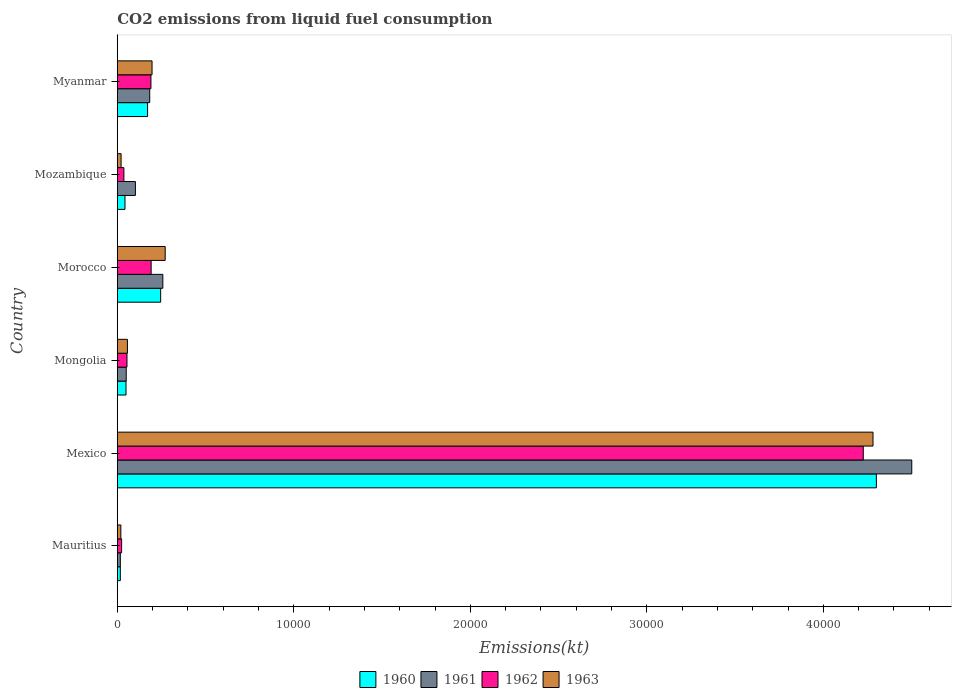Are the number of bars per tick equal to the number of legend labels?
Your answer should be compact. Yes. Are the number of bars on each tick of the Y-axis equal?
Your answer should be very brief. Yes. What is the label of the 5th group of bars from the top?
Give a very brief answer. Mexico. What is the amount of CO2 emitted in 1962 in Mexico?
Offer a terse response. 4.23e+04. Across all countries, what is the maximum amount of CO2 emitted in 1960?
Provide a short and direct response. 4.30e+04. Across all countries, what is the minimum amount of CO2 emitted in 1963?
Offer a terse response. 201.69. In which country was the amount of CO2 emitted in 1963 minimum?
Make the answer very short. Mauritius. What is the total amount of CO2 emitted in 1961 in the graph?
Your response must be concise. 5.11e+04. What is the difference between the amount of CO2 emitted in 1960 in Mexico and that in Myanmar?
Your answer should be very brief. 4.13e+04. What is the difference between the amount of CO2 emitted in 1961 in Morocco and the amount of CO2 emitted in 1963 in Mexico?
Keep it short and to the point. -4.02e+04. What is the average amount of CO2 emitted in 1960 per country?
Offer a very short reply. 8046.62. What is the difference between the amount of CO2 emitted in 1960 and amount of CO2 emitted in 1961 in Myanmar?
Your answer should be very brief. -121.01. What is the ratio of the amount of CO2 emitted in 1963 in Mongolia to that in Myanmar?
Give a very brief answer. 0.29. Is the amount of CO2 emitted in 1960 in Mexico less than that in Morocco?
Your answer should be compact. No. What is the difference between the highest and the second highest amount of CO2 emitted in 1963?
Ensure brevity in your answer.  4.01e+04. What is the difference between the highest and the lowest amount of CO2 emitted in 1962?
Make the answer very short. 4.20e+04. What does the 3rd bar from the top in Mozambique represents?
Make the answer very short. 1961. Is it the case that in every country, the sum of the amount of CO2 emitted in 1961 and amount of CO2 emitted in 1960 is greater than the amount of CO2 emitted in 1963?
Offer a very short reply. Yes. Are all the bars in the graph horizontal?
Provide a short and direct response. Yes. How many countries are there in the graph?
Your answer should be very brief. 6. What is the difference between two consecutive major ticks on the X-axis?
Your answer should be compact. 10000. Are the values on the major ticks of X-axis written in scientific E-notation?
Provide a short and direct response. No. Does the graph contain grids?
Provide a short and direct response. No. Where does the legend appear in the graph?
Provide a succinct answer. Bottom center. How many legend labels are there?
Provide a short and direct response. 4. What is the title of the graph?
Provide a short and direct response. CO2 emissions from liquid fuel consumption. What is the label or title of the X-axis?
Give a very brief answer. Emissions(kt). What is the label or title of the Y-axis?
Provide a succinct answer. Country. What is the Emissions(kt) of 1960 in Mauritius?
Make the answer very short. 172.35. What is the Emissions(kt) in 1961 in Mauritius?
Make the answer very short. 172.35. What is the Emissions(kt) in 1962 in Mauritius?
Make the answer very short. 245.69. What is the Emissions(kt) of 1963 in Mauritius?
Provide a short and direct response. 201.69. What is the Emissions(kt) in 1960 in Mexico?
Provide a short and direct response. 4.30e+04. What is the Emissions(kt) of 1961 in Mexico?
Your response must be concise. 4.50e+04. What is the Emissions(kt) of 1962 in Mexico?
Your response must be concise. 4.23e+04. What is the Emissions(kt) of 1963 in Mexico?
Your response must be concise. 4.28e+04. What is the Emissions(kt) in 1960 in Mongolia?
Provide a succinct answer. 495.05. What is the Emissions(kt) in 1961 in Mongolia?
Give a very brief answer. 506.05. What is the Emissions(kt) in 1962 in Mongolia?
Ensure brevity in your answer.  550.05. What is the Emissions(kt) of 1963 in Mongolia?
Offer a very short reply. 575.72. What is the Emissions(kt) of 1960 in Morocco?
Make the answer very short. 2456.89. What is the Emissions(kt) of 1961 in Morocco?
Offer a terse response. 2581.57. What is the Emissions(kt) of 1962 in Morocco?
Ensure brevity in your answer.  1917.84. What is the Emissions(kt) in 1963 in Morocco?
Your response must be concise. 2713.58. What is the Emissions(kt) of 1960 in Mozambique?
Provide a succinct answer. 436.37. What is the Emissions(kt) in 1961 in Mozambique?
Your answer should be very brief. 1026.76. What is the Emissions(kt) in 1962 in Mozambique?
Give a very brief answer. 374.03. What is the Emissions(kt) of 1963 in Mozambique?
Your response must be concise. 216.35. What is the Emissions(kt) of 1960 in Myanmar?
Keep it short and to the point. 1716.16. What is the Emissions(kt) of 1961 in Myanmar?
Provide a short and direct response. 1837.17. What is the Emissions(kt) of 1962 in Myanmar?
Make the answer very short. 1906.84. What is the Emissions(kt) in 1963 in Myanmar?
Your response must be concise. 1969.18. Across all countries, what is the maximum Emissions(kt) in 1960?
Your answer should be compact. 4.30e+04. Across all countries, what is the maximum Emissions(kt) in 1961?
Make the answer very short. 4.50e+04. Across all countries, what is the maximum Emissions(kt) of 1962?
Provide a succinct answer. 4.23e+04. Across all countries, what is the maximum Emissions(kt) in 1963?
Your answer should be compact. 4.28e+04. Across all countries, what is the minimum Emissions(kt) of 1960?
Provide a succinct answer. 172.35. Across all countries, what is the minimum Emissions(kt) in 1961?
Your answer should be very brief. 172.35. Across all countries, what is the minimum Emissions(kt) of 1962?
Your answer should be very brief. 245.69. Across all countries, what is the minimum Emissions(kt) of 1963?
Your response must be concise. 201.69. What is the total Emissions(kt) of 1960 in the graph?
Offer a terse response. 4.83e+04. What is the total Emissions(kt) of 1961 in the graph?
Your response must be concise. 5.11e+04. What is the total Emissions(kt) in 1962 in the graph?
Your response must be concise. 4.73e+04. What is the total Emissions(kt) in 1963 in the graph?
Offer a very short reply. 4.85e+04. What is the difference between the Emissions(kt) of 1960 in Mauritius and that in Mexico?
Offer a terse response. -4.28e+04. What is the difference between the Emissions(kt) of 1961 in Mauritius and that in Mexico?
Your answer should be very brief. -4.48e+04. What is the difference between the Emissions(kt) of 1962 in Mauritius and that in Mexico?
Your answer should be compact. -4.20e+04. What is the difference between the Emissions(kt) in 1963 in Mauritius and that in Mexico?
Provide a short and direct response. -4.26e+04. What is the difference between the Emissions(kt) of 1960 in Mauritius and that in Mongolia?
Your answer should be very brief. -322.7. What is the difference between the Emissions(kt) of 1961 in Mauritius and that in Mongolia?
Offer a terse response. -333.7. What is the difference between the Emissions(kt) in 1962 in Mauritius and that in Mongolia?
Provide a succinct answer. -304.36. What is the difference between the Emissions(kt) in 1963 in Mauritius and that in Mongolia?
Provide a succinct answer. -374.03. What is the difference between the Emissions(kt) in 1960 in Mauritius and that in Morocco?
Your answer should be compact. -2284.54. What is the difference between the Emissions(kt) in 1961 in Mauritius and that in Morocco?
Provide a short and direct response. -2409.22. What is the difference between the Emissions(kt) in 1962 in Mauritius and that in Morocco?
Ensure brevity in your answer.  -1672.15. What is the difference between the Emissions(kt) of 1963 in Mauritius and that in Morocco?
Ensure brevity in your answer.  -2511.89. What is the difference between the Emissions(kt) in 1960 in Mauritius and that in Mozambique?
Provide a short and direct response. -264.02. What is the difference between the Emissions(kt) of 1961 in Mauritius and that in Mozambique?
Offer a very short reply. -854.41. What is the difference between the Emissions(kt) in 1962 in Mauritius and that in Mozambique?
Keep it short and to the point. -128.34. What is the difference between the Emissions(kt) of 1963 in Mauritius and that in Mozambique?
Make the answer very short. -14.67. What is the difference between the Emissions(kt) in 1960 in Mauritius and that in Myanmar?
Your response must be concise. -1543.81. What is the difference between the Emissions(kt) in 1961 in Mauritius and that in Myanmar?
Keep it short and to the point. -1664.82. What is the difference between the Emissions(kt) of 1962 in Mauritius and that in Myanmar?
Keep it short and to the point. -1661.15. What is the difference between the Emissions(kt) in 1963 in Mauritius and that in Myanmar?
Your answer should be very brief. -1767.49. What is the difference between the Emissions(kt) in 1960 in Mexico and that in Mongolia?
Your answer should be compact. 4.25e+04. What is the difference between the Emissions(kt) in 1961 in Mexico and that in Mongolia?
Provide a succinct answer. 4.45e+04. What is the difference between the Emissions(kt) in 1962 in Mexico and that in Mongolia?
Provide a short and direct response. 4.17e+04. What is the difference between the Emissions(kt) of 1963 in Mexico and that in Mongolia?
Offer a terse response. 4.22e+04. What is the difference between the Emissions(kt) of 1960 in Mexico and that in Morocco?
Ensure brevity in your answer.  4.05e+04. What is the difference between the Emissions(kt) of 1961 in Mexico and that in Morocco?
Provide a succinct answer. 4.24e+04. What is the difference between the Emissions(kt) in 1962 in Mexico and that in Morocco?
Make the answer very short. 4.03e+04. What is the difference between the Emissions(kt) of 1963 in Mexico and that in Morocco?
Your response must be concise. 4.01e+04. What is the difference between the Emissions(kt) in 1960 in Mexico and that in Mozambique?
Provide a succinct answer. 4.26e+04. What is the difference between the Emissions(kt) of 1961 in Mexico and that in Mozambique?
Make the answer very short. 4.40e+04. What is the difference between the Emissions(kt) in 1962 in Mexico and that in Mozambique?
Your answer should be compact. 4.19e+04. What is the difference between the Emissions(kt) in 1963 in Mexico and that in Mozambique?
Your answer should be very brief. 4.26e+04. What is the difference between the Emissions(kt) of 1960 in Mexico and that in Myanmar?
Keep it short and to the point. 4.13e+04. What is the difference between the Emissions(kt) of 1961 in Mexico and that in Myanmar?
Give a very brief answer. 4.32e+04. What is the difference between the Emissions(kt) in 1962 in Mexico and that in Myanmar?
Give a very brief answer. 4.04e+04. What is the difference between the Emissions(kt) in 1963 in Mexico and that in Myanmar?
Your response must be concise. 4.08e+04. What is the difference between the Emissions(kt) in 1960 in Mongolia and that in Morocco?
Offer a terse response. -1961.85. What is the difference between the Emissions(kt) of 1961 in Mongolia and that in Morocco?
Give a very brief answer. -2075.52. What is the difference between the Emissions(kt) of 1962 in Mongolia and that in Morocco?
Your answer should be very brief. -1367.79. What is the difference between the Emissions(kt) of 1963 in Mongolia and that in Morocco?
Your answer should be compact. -2137.86. What is the difference between the Emissions(kt) of 1960 in Mongolia and that in Mozambique?
Offer a very short reply. 58.67. What is the difference between the Emissions(kt) of 1961 in Mongolia and that in Mozambique?
Provide a short and direct response. -520.71. What is the difference between the Emissions(kt) in 1962 in Mongolia and that in Mozambique?
Give a very brief answer. 176.02. What is the difference between the Emissions(kt) in 1963 in Mongolia and that in Mozambique?
Give a very brief answer. 359.37. What is the difference between the Emissions(kt) in 1960 in Mongolia and that in Myanmar?
Offer a terse response. -1221.11. What is the difference between the Emissions(kt) in 1961 in Mongolia and that in Myanmar?
Provide a succinct answer. -1331.12. What is the difference between the Emissions(kt) of 1962 in Mongolia and that in Myanmar?
Ensure brevity in your answer.  -1356.79. What is the difference between the Emissions(kt) in 1963 in Mongolia and that in Myanmar?
Keep it short and to the point. -1393.46. What is the difference between the Emissions(kt) in 1960 in Morocco and that in Mozambique?
Your answer should be very brief. 2020.52. What is the difference between the Emissions(kt) in 1961 in Morocco and that in Mozambique?
Keep it short and to the point. 1554.81. What is the difference between the Emissions(kt) of 1962 in Morocco and that in Mozambique?
Ensure brevity in your answer.  1543.81. What is the difference between the Emissions(kt) of 1963 in Morocco and that in Mozambique?
Give a very brief answer. 2497.23. What is the difference between the Emissions(kt) in 1960 in Morocco and that in Myanmar?
Provide a succinct answer. 740.73. What is the difference between the Emissions(kt) in 1961 in Morocco and that in Myanmar?
Offer a terse response. 744.4. What is the difference between the Emissions(kt) in 1962 in Morocco and that in Myanmar?
Your response must be concise. 11. What is the difference between the Emissions(kt) of 1963 in Morocco and that in Myanmar?
Make the answer very short. 744.4. What is the difference between the Emissions(kt) in 1960 in Mozambique and that in Myanmar?
Provide a short and direct response. -1279.78. What is the difference between the Emissions(kt) in 1961 in Mozambique and that in Myanmar?
Your response must be concise. -810.41. What is the difference between the Emissions(kt) in 1962 in Mozambique and that in Myanmar?
Offer a very short reply. -1532.81. What is the difference between the Emissions(kt) in 1963 in Mozambique and that in Myanmar?
Provide a succinct answer. -1752.83. What is the difference between the Emissions(kt) of 1960 in Mauritius and the Emissions(kt) of 1961 in Mexico?
Make the answer very short. -4.48e+04. What is the difference between the Emissions(kt) of 1960 in Mauritius and the Emissions(kt) of 1962 in Mexico?
Keep it short and to the point. -4.21e+04. What is the difference between the Emissions(kt) of 1960 in Mauritius and the Emissions(kt) of 1963 in Mexico?
Your answer should be very brief. -4.26e+04. What is the difference between the Emissions(kt) in 1961 in Mauritius and the Emissions(kt) in 1962 in Mexico?
Provide a short and direct response. -4.21e+04. What is the difference between the Emissions(kt) in 1961 in Mauritius and the Emissions(kt) in 1963 in Mexico?
Your answer should be very brief. -4.26e+04. What is the difference between the Emissions(kt) in 1962 in Mauritius and the Emissions(kt) in 1963 in Mexico?
Offer a very short reply. -4.26e+04. What is the difference between the Emissions(kt) of 1960 in Mauritius and the Emissions(kt) of 1961 in Mongolia?
Give a very brief answer. -333.7. What is the difference between the Emissions(kt) in 1960 in Mauritius and the Emissions(kt) in 1962 in Mongolia?
Provide a short and direct response. -377.7. What is the difference between the Emissions(kt) of 1960 in Mauritius and the Emissions(kt) of 1963 in Mongolia?
Make the answer very short. -403.37. What is the difference between the Emissions(kt) of 1961 in Mauritius and the Emissions(kt) of 1962 in Mongolia?
Provide a short and direct response. -377.7. What is the difference between the Emissions(kt) of 1961 in Mauritius and the Emissions(kt) of 1963 in Mongolia?
Ensure brevity in your answer.  -403.37. What is the difference between the Emissions(kt) of 1962 in Mauritius and the Emissions(kt) of 1963 in Mongolia?
Provide a succinct answer. -330.03. What is the difference between the Emissions(kt) in 1960 in Mauritius and the Emissions(kt) in 1961 in Morocco?
Provide a succinct answer. -2409.22. What is the difference between the Emissions(kt) of 1960 in Mauritius and the Emissions(kt) of 1962 in Morocco?
Offer a very short reply. -1745.49. What is the difference between the Emissions(kt) of 1960 in Mauritius and the Emissions(kt) of 1963 in Morocco?
Make the answer very short. -2541.23. What is the difference between the Emissions(kt) of 1961 in Mauritius and the Emissions(kt) of 1962 in Morocco?
Make the answer very short. -1745.49. What is the difference between the Emissions(kt) in 1961 in Mauritius and the Emissions(kt) in 1963 in Morocco?
Give a very brief answer. -2541.23. What is the difference between the Emissions(kt) in 1962 in Mauritius and the Emissions(kt) in 1963 in Morocco?
Your response must be concise. -2467.89. What is the difference between the Emissions(kt) of 1960 in Mauritius and the Emissions(kt) of 1961 in Mozambique?
Provide a succinct answer. -854.41. What is the difference between the Emissions(kt) in 1960 in Mauritius and the Emissions(kt) in 1962 in Mozambique?
Offer a very short reply. -201.69. What is the difference between the Emissions(kt) of 1960 in Mauritius and the Emissions(kt) of 1963 in Mozambique?
Your response must be concise. -44. What is the difference between the Emissions(kt) of 1961 in Mauritius and the Emissions(kt) of 1962 in Mozambique?
Your answer should be compact. -201.69. What is the difference between the Emissions(kt) in 1961 in Mauritius and the Emissions(kt) in 1963 in Mozambique?
Provide a succinct answer. -44. What is the difference between the Emissions(kt) of 1962 in Mauritius and the Emissions(kt) of 1963 in Mozambique?
Offer a very short reply. 29.34. What is the difference between the Emissions(kt) in 1960 in Mauritius and the Emissions(kt) in 1961 in Myanmar?
Your response must be concise. -1664.82. What is the difference between the Emissions(kt) in 1960 in Mauritius and the Emissions(kt) in 1962 in Myanmar?
Provide a short and direct response. -1734.49. What is the difference between the Emissions(kt) in 1960 in Mauritius and the Emissions(kt) in 1963 in Myanmar?
Give a very brief answer. -1796.83. What is the difference between the Emissions(kt) in 1961 in Mauritius and the Emissions(kt) in 1962 in Myanmar?
Your answer should be compact. -1734.49. What is the difference between the Emissions(kt) in 1961 in Mauritius and the Emissions(kt) in 1963 in Myanmar?
Your answer should be compact. -1796.83. What is the difference between the Emissions(kt) of 1962 in Mauritius and the Emissions(kt) of 1963 in Myanmar?
Provide a succinct answer. -1723.49. What is the difference between the Emissions(kt) in 1960 in Mexico and the Emissions(kt) in 1961 in Mongolia?
Your response must be concise. 4.25e+04. What is the difference between the Emissions(kt) of 1960 in Mexico and the Emissions(kt) of 1962 in Mongolia?
Provide a succinct answer. 4.25e+04. What is the difference between the Emissions(kt) in 1960 in Mexico and the Emissions(kt) in 1963 in Mongolia?
Offer a very short reply. 4.24e+04. What is the difference between the Emissions(kt) of 1961 in Mexico and the Emissions(kt) of 1962 in Mongolia?
Offer a terse response. 4.45e+04. What is the difference between the Emissions(kt) in 1961 in Mexico and the Emissions(kt) in 1963 in Mongolia?
Your answer should be very brief. 4.44e+04. What is the difference between the Emissions(kt) of 1962 in Mexico and the Emissions(kt) of 1963 in Mongolia?
Your response must be concise. 4.17e+04. What is the difference between the Emissions(kt) of 1960 in Mexico and the Emissions(kt) of 1961 in Morocco?
Keep it short and to the point. 4.04e+04. What is the difference between the Emissions(kt) in 1960 in Mexico and the Emissions(kt) in 1962 in Morocco?
Provide a short and direct response. 4.11e+04. What is the difference between the Emissions(kt) in 1960 in Mexico and the Emissions(kt) in 1963 in Morocco?
Offer a terse response. 4.03e+04. What is the difference between the Emissions(kt) in 1961 in Mexico and the Emissions(kt) in 1962 in Morocco?
Your answer should be compact. 4.31e+04. What is the difference between the Emissions(kt) of 1961 in Mexico and the Emissions(kt) of 1963 in Morocco?
Provide a short and direct response. 4.23e+04. What is the difference between the Emissions(kt) of 1962 in Mexico and the Emissions(kt) of 1963 in Morocco?
Your answer should be compact. 3.95e+04. What is the difference between the Emissions(kt) in 1960 in Mexico and the Emissions(kt) in 1961 in Mozambique?
Your answer should be compact. 4.20e+04. What is the difference between the Emissions(kt) in 1960 in Mexico and the Emissions(kt) in 1962 in Mozambique?
Give a very brief answer. 4.26e+04. What is the difference between the Emissions(kt) of 1960 in Mexico and the Emissions(kt) of 1963 in Mozambique?
Provide a succinct answer. 4.28e+04. What is the difference between the Emissions(kt) of 1961 in Mexico and the Emissions(kt) of 1962 in Mozambique?
Offer a terse response. 4.46e+04. What is the difference between the Emissions(kt) in 1961 in Mexico and the Emissions(kt) in 1963 in Mozambique?
Your response must be concise. 4.48e+04. What is the difference between the Emissions(kt) of 1962 in Mexico and the Emissions(kt) of 1963 in Mozambique?
Provide a short and direct response. 4.20e+04. What is the difference between the Emissions(kt) in 1960 in Mexico and the Emissions(kt) in 1961 in Myanmar?
Offer a very short reply. 4.12e+04. What is the difference between the Emissions(kt) of 1960 in Mexico and the Emissions(kt) of 1962 in Myanmar?
Make the answer very short. 4.11e+04. What is the difference between the Emissions(kt) in 1960 in Mexico and the Emissions(kt) in 1963 in Myanmar?
Ensure brevity in your answer.  4.10e+04. What is the difference between the Emissions(kt) of 1961 in Mexico and the Emissions(kt) of 1962 in Myanmar?
Offer a very short reply. 4.31e+04. What is the difference between the Emissions(kt) of 1961 in Mexico and the Emissions(kt) of 1963 in Myanmar?
Your response must be concise. 4.30e+04. What is the difference between the Emissions(kt) of 1962 in Mexico and the Emissions(kt) of 1963 in Myanmar?
Make the answer very short. 4.03e+04. What is the difference between the Emissions(kt) of 1960 in Mongolia and the Emissions(kt) of 1961 in Morocco?
Keep it short and to the point. -2086.52. What is the difference between the Emissions(kt) in 1960 in Mongolia and the Emissions(kt) in 1962 in Morocco?
Your answer should be very brief. -1422.8. What is the difference between the Emissions(kt) in 1960 in Mongolia and the Emissions(kt) in 1963 in Morocco?
Make the answer very short. -2218.53. What is the difference between the Emissions(kt) of 1961 in Mongolia and the Emissions(kt) of 1962 in Morocco?
Keep it short and to the point. -1411.8. What is the difference between the Emissions(kt) in 1961 in Mongolia and the Emissions(kt) in 1963 in Morocco?
Give a very brief answer. -2207.53. What is the difference between the Emissions(kt) of 1962 in Mongolia and the Emissions(kt) of 1963 in Morocco?
Keep it short and to the point. -2163.53. What is the difference between the Emissions(kt) in 1960 in Mongolia and the Emissions(kt) in 1961 in Mozambique?
Offer a very short reply. -531.72. What is the difference between the Emissions(kt) of 1960 in Mongolia and the Emissions(kt) of 1962 in Mozambique?
Your answer should be compact. 121.01. What is the difference between the Emissions(kt) of 1960 in Mongolia and the Emissions(kt) of 1963 in Mozambique?
Ensure brevity in your answer.  278.69. What is the difference between the Emissions(kt) in 1961 in Mongolia and the Emissions(kt) in 1962 in Mozambique?
Provide a succinct answer. 132.01. What is the difference between the Emissions(kt) in 1961 in Mongolia and the Emissions(kt) in 1963 in Mozambique?
Provide a short and direct response. 289.69. What is the difference between the Emissions(kt) in 1962 in Mongolia and the Emissions(kt) in 1963 in Mozambique?
Your answer should be very brief. 333.7. What is the difference between the Emissions(kt) in 1960 in Mongolia and the Emissions(kt) in 1961 in Myanmar?
Your response must be concise. -1342.12. What is the difference between the Emissions(kt) of 1960 in Mongolia and the Emissions(kt) of 1962 in Myanmar?
Your answer should be compact. -1411.8. What is the difference between the Emissions(kt) in 1960 in Mongolia and the Emissions(kt) in 1963 in Myanmar?
Your response must be concise. -1474.13. What is the difference between the Emissions(kt) in 1961 in Mongolia and the Emissions(kt) in 1962 in Myanmar?
Provide a short and direct response. -1400.79. What is the difference between the Emissions(kt) in 1961 in Mongolia and the Emissions(kt) in 1963 in Myanmar?
Make the answer very short. -1463.13. What is the difference between the Emissions(kt) of 1962 in Mongolia and the Emissions(kt) of 1963 in Myanmar?
Your response must be concise. -1419.13. What is the difference between the Emissions(kt) of 1960 in Morocco and the Emissions(kt) of 1961 in Mozambique?
Your answer should be very brief. 1430.13. What is the difference between the Emissions(kt) in 1960 in Morocco and the Emissions(kt) in 1962 in Mozambique?
Provide a short and direct response. 2082.86. What is the difference between the Emissions(kt) in 1960 in Morocco and the Emissions(kt) in 1963 in Mozambique?
Offer a very short reply. 2240.54. What is the difference between the Emissions(kt) in 1961 in Morocco and the Emissions(kt) in 1962 in Mozambique?
Keep it short and to the point. 2207.53. What is the difference between the Emissions(kt) in 1961 in Morocco and the Emissions(kt) in 1963 in Mozambique?
Your answer should be compact. 2365.22. What is the difference between the Emissions(kt) of 1962 in Morocco and the Emissions(kt) of 1963 in Mozambique?
Ensure brevity in your answer.  1701.49. What is the difference between the Emissions(kt) of 1960 in Morocco and the Emissions(kt) of 1961 in Myanmar?
Ensure brevity in your answer.  619.72. What is the difference between the Emissions(kt) of 1960 in Morocco and the Emissions(kt) of 1962 in Myanmar?
Offer a terse response. 550.05. What is the difference between the Emissions(kt) in 1960 in Morocco and the Emissions(kt) in 1963 in Myanmar?
Keep it short and to the point. 487.71. What is the difference between the Emissions(kt) of 1961 in Morocco and the Emissions(kt) of 1962 in Myanmar?
Provide a succinct answer. 674.73. What is the difference between the Emissions(kt) of 1961 in Morocco and the Emissions(kt) of 1963 in Myanmar?
Make the answer very short. 612.39. What is the difference between the Emissions(kt) of 1962 in Morocco and the Emissions(kt) of 1963 in Myanmar?
Your answer should be compact. -51.34. What is the difference between the Emissions(kt) of 1960 in Mozambique and the Emissions(kt) of 1961 in Myanmar?
Your answer should be compact. -1400.79. What is the difference between the Emissions(kt) of 1960 in Mozambique and the Emissions(kt) of 1962 in Myanmar?
Your answer should be compact. -1470.47. What is the difference between the Emissions(kt) in 1960 in Mozambique and the Emissions(kt) in 1963 in Myanmar?
Offer a very short reply. -1532.81. What is the difference between the Emissions(kt) of 1961 in Mozambique and the Emissions(kt) of 1962 in Myanmar?
Offer a very short reply. -880.08. What is the difference between the Emissions(kt) in 1961 in Mozambique and the Emissions(kt) in 1963 in Myanmar?
Offer a terse response. -942.42. What is the difference between the Emissions(kt) of 1962 in Mozambique and the Emissions(kt) of 1963 in Myanmar?
Provide a succinct answer. -1595.14. What is the average Emissions(kt) of 1960 per country?
Offer a terse response. 8046.62. What is the average Emissions(kt) in 1961 per country?
Provide a short and direct response. 8522.11. What is the average Emissions(kt) in 1962 per country?
Offer a terse response. 7876.1. What is the average Emissions(kt) in 1963 per country?
Make the answer very short. 8081.46. What is the difference between the Emissions(kt) of 1960 and Emissions(kt) of 1961 in Mauritius?
Provide a short and direct response. 0. What is the difference between the Emissions(kt) of 1960 and Emissions(kt) of 1962 in Mauritius?
Offer a very short reply. -73.34. What is the difference between the Emissions(kt) in 1960 and Emissions(kt) in 1963 in Mauritius?
Your response must be concise. -29.34. What is the difference between the Emissions(kt) of 1961 and Emissions(kt) of 1962 in Mauritius?
Provide a short and direct response. -73.34. What is the difference between the Emissions(kt) of 1961 and Emissions(kt) of 1963 in Mauritius?
Keep it short and to the point. -29.34. What is the difference between the Emissions(kt) in 1962 and Emissions(kt) in 1963 in Mauritius?
Your response must be concise. 44. What is the difference between the Emissions(kt) in 1960 and Emissions(kt) in 1961 in Mexico?
Make the answer very short. -2005.85. What is the difference between the Emissions(kt) in 1960 and Emissions(kt) in 1962 in Mexico?
Make the answer very short. 740.73. What is the difference between the Emissions(kt) of 1960 and Emissions(kt) of 1963 in Mexico?
Your response must be concise. 190.68. What is the difference between the Emissions(kt) of 1961 and Emissions(kt) of 1962 in Mexico?
Give a very brief answer. 2746.58. What is the difference between the Emissions(kt) of 1961 and Emissions(kt) of 1963 in Mexico?
Offer a very short reply. 2196.53. What is the difference between the Emissions(kt) of 1962 and Emissions(kt) of 1963 in Mexico?
Keep it short and to the point. -550.05. What is the difference between the Emissions(kt) of 1960 and Emissions(kt) of 1961 in Mongolia?
Offer a very short reply. -11. What is the difference between the Emissions(kt) of 1960 and Emissions(kt) of 1962 in Mongolia?
Provide a succinct answer. -55.01. What is the difference between the Emissions(kt) in 1960 and Emissions(kt) in 1963 in Mongolia?
Provide a succinct answer. -80.67. What is the difference between the Emissions(kt) of 1961 and Emissions(kt) of 1962 in Mongolia?
Keep it short and to the point. -44. What is the difference between the Emissions(kt) in 1961 and Emissions(kt) in 1963 in Mongolia?
Offer a terse response. -69.67. What is the difference between the Emissions(kt) in 1962 and Emissions(kt) in 1963 in Mongolia?
Offer a very short reply. -25.67. What is the difference between the Emissions(kt) of 1960 and Emissions(kt) of 1961 in Morocco?
Your response must be concise. -124.68. What is the difference between the Emissions(kt) in 1960 and Emissions(kt) in 1962 in Morocco?
Offer a terse response. 539.05. What is the difference between the Emissions(kt) of 1960 and Emissions(kt) of 1963 in Morocco?
Offer a very short reply. -256.69. What is the difference between the Emissions(kt) of 1961 and Emissions(kt) of 1962 in Morocco?
Your answer should be compact. 663.73. What is the difference between the Emissions(kt) of 1961 and Emissions(kt) of 1963 in Morocco?
Your answer should be compact. -132.01. What is the difference between the Emissions(kt) of 1962 and Emissions(kt) of 1963 in Morocco?
Your answer should be very brief. -795.74. What is the difference between the Emissions(kt) in 1960 and Emissions(kt) in 1961 in Mozambique?
Your answer should be compact. -590.39. What is the difference between the Emissions(kt) of 1960 and Emissions(kt) of 1962 in Mozambique?
Give a very brief answer. 62.34. What is the difference between the Emissions(kt) in 1960 and Emissions(kt) in 1963 in Mozambique?
Ensure brevity in your answer.  220.02. What is the difference between the Emissions(kt) of 1961 and Emissions(kt) of 1962 in Mozambique?
Make the answer very short. 652.73. What is the difference between the Emissions(kt) in 1961 and Emissions(kt) in 1963 in Mozambique?
Your answer should be very brief. 810.41. What is the difference between the Emissions(kt) of 1962 and Emissions(kt) of 1963 in Mozambique?
Make the answer very short. 157.68. What is the difference between the Emissions(kt) in 1960 and Emissions(kt) in 1961 in Myanmar?
Your answer should be compact. -121.01. What is the difference between the Emissions(kt) of 1960 and Emissions(kt) of 1962 in Myanmar?
Your answer should be compact. -190.68. What is the difference between the Emissions(kt) in 1960 and Emissions(kt) in 1963 in Myanmar?
Offer a very short reply. -253.02. What is the difference between the Emissions(kt) in 1961 and Emissions(kt) in 1962 in Myanmar?
Ensure brevity in your answer.  -69.67. What is the difference between the Emissions(kt) of 1961 and Emissions(kt) of 1963 in Myanmar?
Offer a very short reply. -132.01. What is the difference between the Emissions(kt) in 1962 and Emissions(kt) in 1963 in Myanmar?
Ensure brevity in your answer.  -62.34. What is the ratio of the Emissions(kt) of 1960 in Mauritius to that in Mexico?
Provide a succinct answer. 0. What is the ratio of the Emissions(kt) in 1961 in Mauritius to that in Mexico?
Your answer should be very brief. 0. What is the ratio of the Emissions(kt) of 1962 in Mauritius to that in Mexico?
Your answer should be compact. 0.01. What is the ratio of the Emissions(kt) in 1963 in Mauritius to that in Mexico?
Your answer should be very brief. 0. What is the ratio of the Emissions(kt) of 1960 in Mauritius to that in Mongolia?
Your answer should be compact. 0.35. What is the ratio of the Emissions(kt) of 1961 in Mauritius to that in Mongolia?
Ensure brevity in your answer.  0.34. What is the ratio of the Emissions(kt) of 1962 in Mauritius to that in Mongolia?
Ensure brevity in your answer.  0.45. What is the ratio of the Emissions(kt) of 1963 in Mauritius to that in Mongolia?
Offer a terse response. 0.35. What is the ratio of the Emissions(kt) in 1960 in Mauritius to that in Morocco?
Provide a succinct answer. 0.07. What is the ratio of the Emissions(kt) in 1961 in Mauritius to that in Morocco?
Your answer should be compact. 0.07. What is the ratio of the Emissions(kt) in 1962 in Mauritius to that in Morocco?
Provide a succinct answer. 0.13. What is the ratio of the Emissions(kt) of 1963 in Mauritius to that in Morocco?
Offer a terse response. 0.07. What is the ratio of the Emissions(kt) in 1960 in Mauritius to that in Mozambique?
Ensure brevity in your answer.  0.4. What is the ratio of the Emissions(kt) in 1961 in Mauritius to that in Mozambique?
Offer a terse response. 0.17. What is the ratio of the Emissions(kt) in 1962 in Mauritius to that in Mozambique?
Ensure brevity in your answer.  0.66. What is the ratio of the Emissions(kt) of 1963 in Mauritius to that in Mozambique?
Your answer should be compact. 0.93. What is the ratio of the Emissions(kt) of 1960 in Mauritius to that in Myanmar?
Give a very brief answer. 0.1. What is the ratio of the Emissions(kt) in 1961 in Mauritius to that in Myanmar?
Provide a succinct answer. 0.09. What is the ratio of the Emissions(kt) in 1962 in Mauritius to that in Myanmar?
Offer a terse response. 0.13. What is the ratio of the Emissions(kt) of 1963 in Mauritius to that in Myanmar?
Your answer should be compact. 0.1. What is the ratio of the Emissions(kt) of 1960 in Mexico to that in Mongolia?
Offer a terse response. 86.87. What is the ratio of the Emissions(kt) in 1961 in Mexico to that in Mongolia?
Provide a succinct answer. 88.94. What is the ratio of the Emissions(kt) of 1962 in Mexico to that in Mongolia?
Your answer should be compact. 76.83. What is the ratio of the Emissions(kt) in 1963 in Mexico to that in Mongolia?
Offer a very short reply. 74.36. What is the ratio of the Emissions(kt) in 1960 in Mexico to that in Morocco?
Your response must be concise. 17.5. What is the ratio of the Emissions(kt) of 1961 in Mexico to that in Morocco?
Keep it short and to the point. 17.43. What is the ratio of the Emissions(kt) in 1962 in Mexico to that in Morocco?
Your answer should be compact. 22.04. What is the ratio of the Emissions(kt) in 1963 in Mexico to that in Morocco?
Your answer should be compact. 15.78. What is the ratio of the Emissions(kt) in 1960 in Mexico to that in Mozambique?
Your answer should be compact. 98.55. What is the ratio of the Emissions(kt) in 1961 in Mexico to that in Mozambique?
Your answer should be very brief. 43.84. What is the ratio of the Emissions(kt) in 1962 in Mexico to that in Mozambique?
Provide a succinct answer. 112.99. What is the ratio of the Emissions(kt) in 1963 in Mexico to that in Mozambique?
Your answer should be compact. 197.88. What is the ratio of the Emissions(kt) in 1960 in Mexico to that in Myanmar?
Your response must be concise. 25.06. What is the ratio of the Emissions(kt) of 1961 in Mexico to that in Myanmar?
Keep it short and to the point. 24.5. What is the ratio of the Emissions(kt) of 1962 in Mexico to that in Myanmar?
Give a very brief answer. 22.16. What is the ratio of the Emissions(kt) in 1963 in Mexico to that in Myanmar?
Your response must be concise. 21.74. What is the ratio of the Emissions(kt) of 1960 in Mongolia to that in Morocco?
Your answer should be very brief. 0.2. What is the ratio of the Emissions(kt) in 1961 in Mongolia to that in Morocco?
Give a very brief answer. 0.2. What is the ratio of the Emissions(kt) in 1962 in Mongolia to that in Morocco?
Ensure brevity in your answer.  0.29. What is the ratio of the Emissions(kt) in 1963 in Mongolia to that in Morocco?
Your answer should be compact. 0.21. What is the ratio of the Emissions(kt) of 1960 in Mongolia to that in Mozambique?
Offer a terse response. 1.13. What is the ratio of the Emissions(kt) of 1961 in Mongolia to that in Mozambique?
Ensure brevity in your answer.  0.49. What is the ratio of the Emissions(kt) of 1962 in Mongolia to that in Mozambique?
Your response must be concise. 1.47. What is the ratio of the Emissions(kt) in 1963 in Mongolia to that in Mozambique?
Offer a terse response. 2.66. What is the ratio of the Emissions(kt) of 1960 in Mongolia to that in Myanmar?
Offer a terse response. 0.29. What is the ratio of the Emissions(kt) of 1961 in Mongolia to that in Myanmar?
Give a very brief answer. 0.28. What is the ratio of the Emissions(kt) in 1962 in Mongolia to that in Myanmar?
Offer a terse response. 0.29. What is the ratio of the Emissions(kt) in 1963 in Mongolia to that in Myanmar?
Offer a very short reply. 0.29. What is the ratio of the Emissions(kt) of 1960 in Morocco to that in Mozambique?
Offer a terse response. 5.63. What is the ratio of the Emissions(kt) in 1961 in Morocco to that in Mozambique?
Your response must be concise. 2.51. What is the ratio of the Emissions(kt) in 1962 in Morocco to that in Mozambique?
Your answer should be very brief. 5.13. What is the ratio of the Emissions(kt) in 1963 in Morocco to that in Mozambique?
Offer a terse response. 12.54. What is the ratio of the Emissions(kt) of 1960 in Morocco to that in Myanmar?
Offer a terse response. 1.43. What is the ratio of the Emissions(kt) of 1961 in Morocco to that in Myanmar?
Your answer should be very brief. 1.41. What is the ratio of the Emissions(kt) in 1963 in Morocco to that in Myanmar?
Provide a short and direct response. 1.38. What is the ratio of the Emissions(kt) of 1960 in Mozambique to that in Myanmar?
Keep it short and to the point. 0.25. What is the ratio of the Emissions(kt) in 1961 in Mozambique to that in Myanmar?
Your answer should be compact. 0.56. What is the ratio of the Emissions(kt) of 1962 in Mozambique to that in Myanmar?
Your response must be concise. 0.2. What is the ratio of the Emissions(kt) in 1963 in Mozambique to that in Myanmar?
Offer a terse response. 0.11. What is the difference between the highest and the second highest Emissions(kt) of 1960?
Provide a short and direct response. 4.05e+04. What is the difference between the highest and the second highest Emissions(kt) of 1961?
Offer a very short reply. 4.24e+04. What is the difference between the highest and the second highest Emissions(kt) of 1962?
Your answer should be very brief. 4.03e+04. What is the difference between the highest and the second highest Emissions(kt) in 1963?
Your response must be concise. 4.01e+04. What is the difference between the highest and the lowest Emissions(kt) of 1960?
Offer a very short reply. 4.28e+04. What is the difference between the highest and the lowest Emissions(kt) of 1961?
Your answer should be very brief. 4.48e+04. What is the difference between the highest and the lowest Emissions(kt) in 1962?
Give a very brief answer. 4.20e+04. What is the difference between the highest and the lowest Emissions(kt) of 1963?
Give a very brief answer. 4.26e+04. 